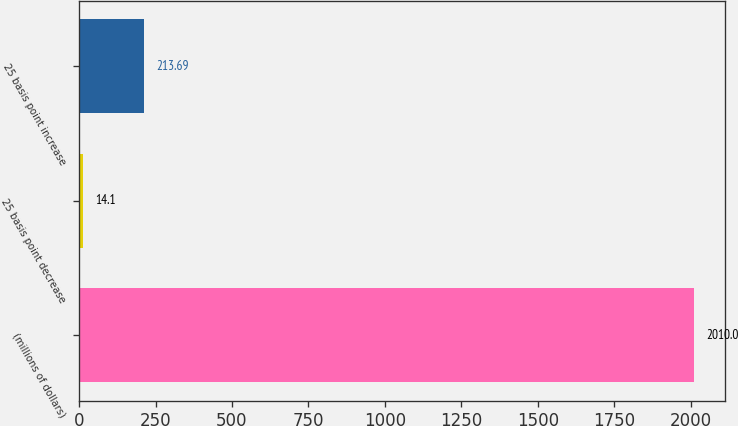Convert chart to OTSL. <chart><loc_0><loc_0><loc_500><loc_500><bar_chart><fcel>(millions of dollars)<fcel>25 basis point decrease<fcel>25 basis point increase<nl><fcel>2010<fcel>14.1<fcel>213.69<nl></chart> 